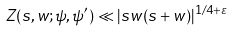Convert formula to latex. <formula><loc_0><loc_0><loc_500><loc_500>Z ( s , w ; \psi , \psi ^ { \prime } ) \ll | s w ( s + w ) | ^ { 1 / 4 + \varepsilon }</formula> 